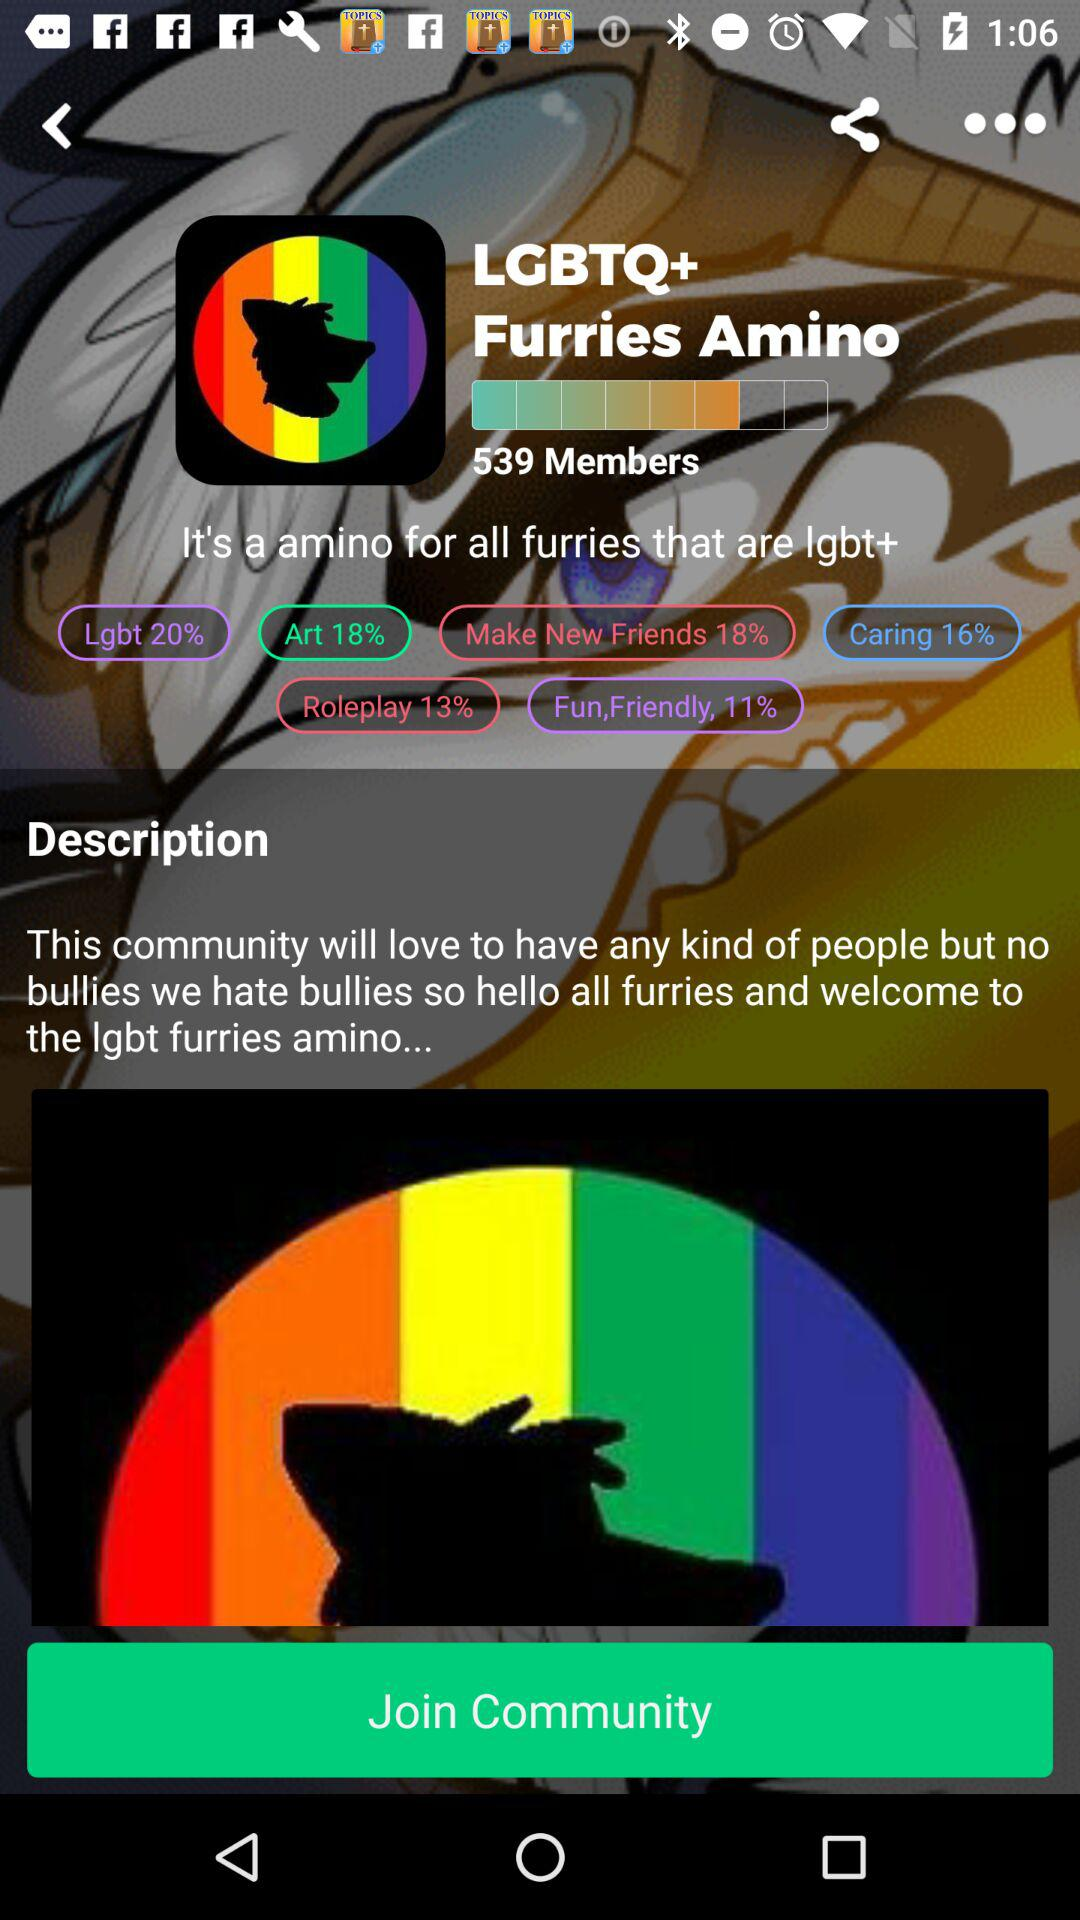How many percent of the community is made up of people who are interested in art?
Answer the question using a single word or phrase. 18% 